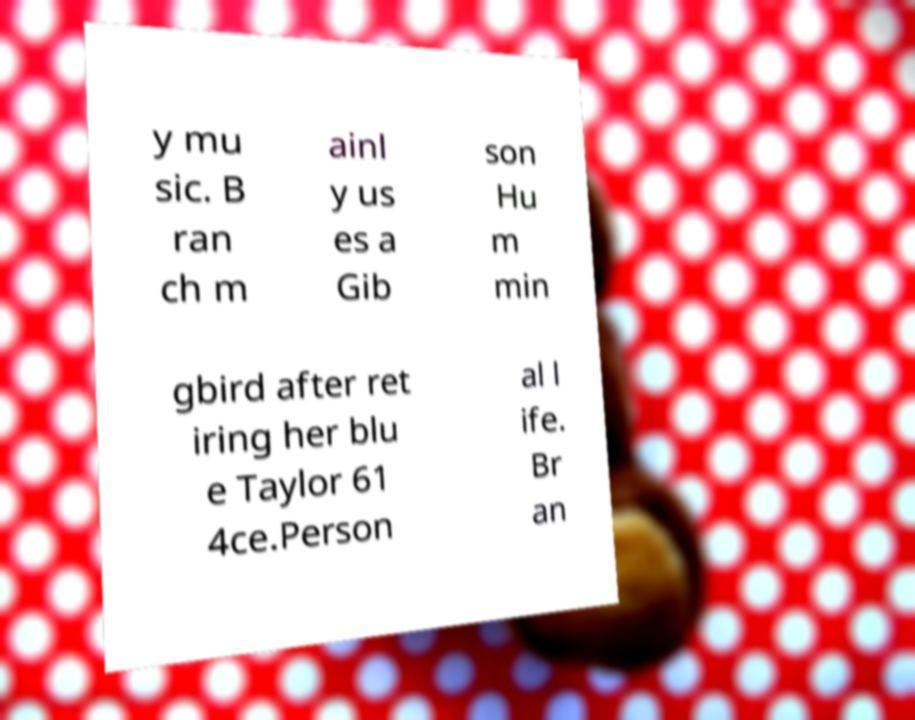I need the written content from this picture converted into text. Can you do that? y mu sic. B ran ch m ainl y us es a Gib son Hu m min gbird after ret iring her blu e Taylor 61 4ce.Person al l ife. Br an 